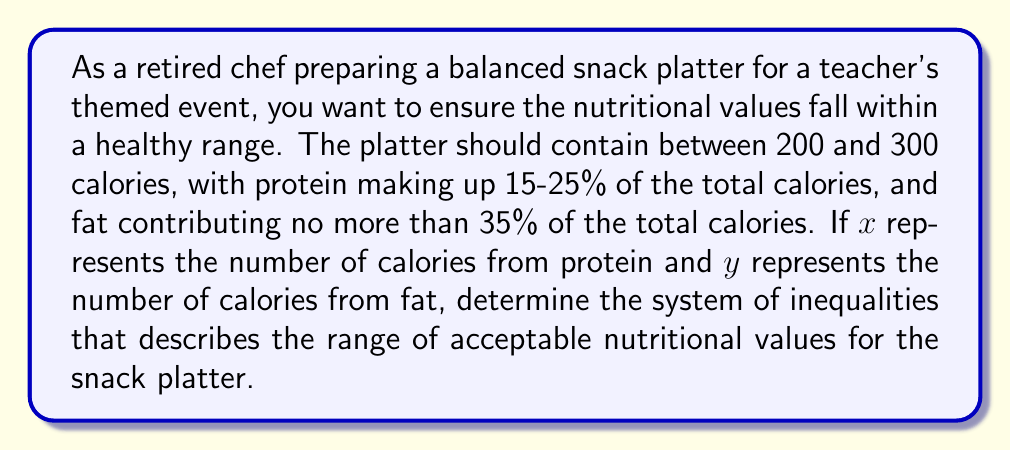Help me with this question. Let's break this down step-by-step:

1) First, we need to express the total calorie range:
   $$ 200 \leq \text{Total Calories} \leq 300 $$

2) Now, let's define our variables:
   x = calories from protein
   y = calories from fat
   (Total Calories - x - y) = calories from carbohydrates

3) For protein, we're told it should be 15-25% of total calories. This gives us:
   $$ 0.15 \cdot \text{Total Calories} \leq x \leq 0.25 \cdot \text{Total Calories} $$
   Substituting the range for Total Calories:
   $$ 0.15 \cdot 200 \leq x \leq 0.25 \cdot 300 $$
   $$ 30 \leq x \leq 75 $$

4) For fat, we're told it should be no more than 35% of total calories:
   $$ y \leq 0.35 \cdot \text{Total Calories} $$
   Using the upper limit of Total Calories:
   $$ y \leq 0.35 \cdot 300 = 105 $$

5) We also know that x, y, and (Total Calories - x - y) must sum to the total calories:
   $$ 200 \leq x + y + (\text{Total Calories} - x - y) \leq 300 $$
   This simplifies to our first inequality.

6) Lastly, we need to ensure x and y are non-negative:
   $$ x \geq 0, y \geq 0 $$

Combining all these inequalities gives us our system.
Answer: The system of inequalities describing the range of acceptable nutritional values is:

$$ \begin{cases}
200 \leq x + y \leq 300 \\
30 \leq x \leq 75 \\
0 \leq y \leq 105 \\
x \geq 0, y \geq 0
\end{cases} $$ 